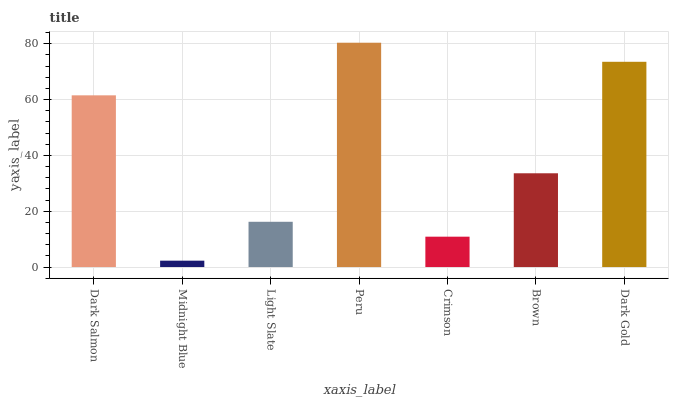Is Light Slate the minimum?
Answer yes or no. No. Is Light Slate the maximum?
Answer yes or no. No. Is Light Slate greater than Midnight Blue?
Answer yes or no. Yes. Is Midnight Blue less than Light Slate?
Answer yes or no. Yes. Is Midnight Blue greater than Light Slate?
Answer yes or no. No. Is Light Slate less than Midnight Blue?
Answer yes or no. No. Is Brown the high median?
Answer yes or no. Yes. Is Brown the low median?
Answer yes or no. Yes. Is Peru the high median?
Answer yes or no. No. Is Peru the low median?
Answer yes or no. No. 